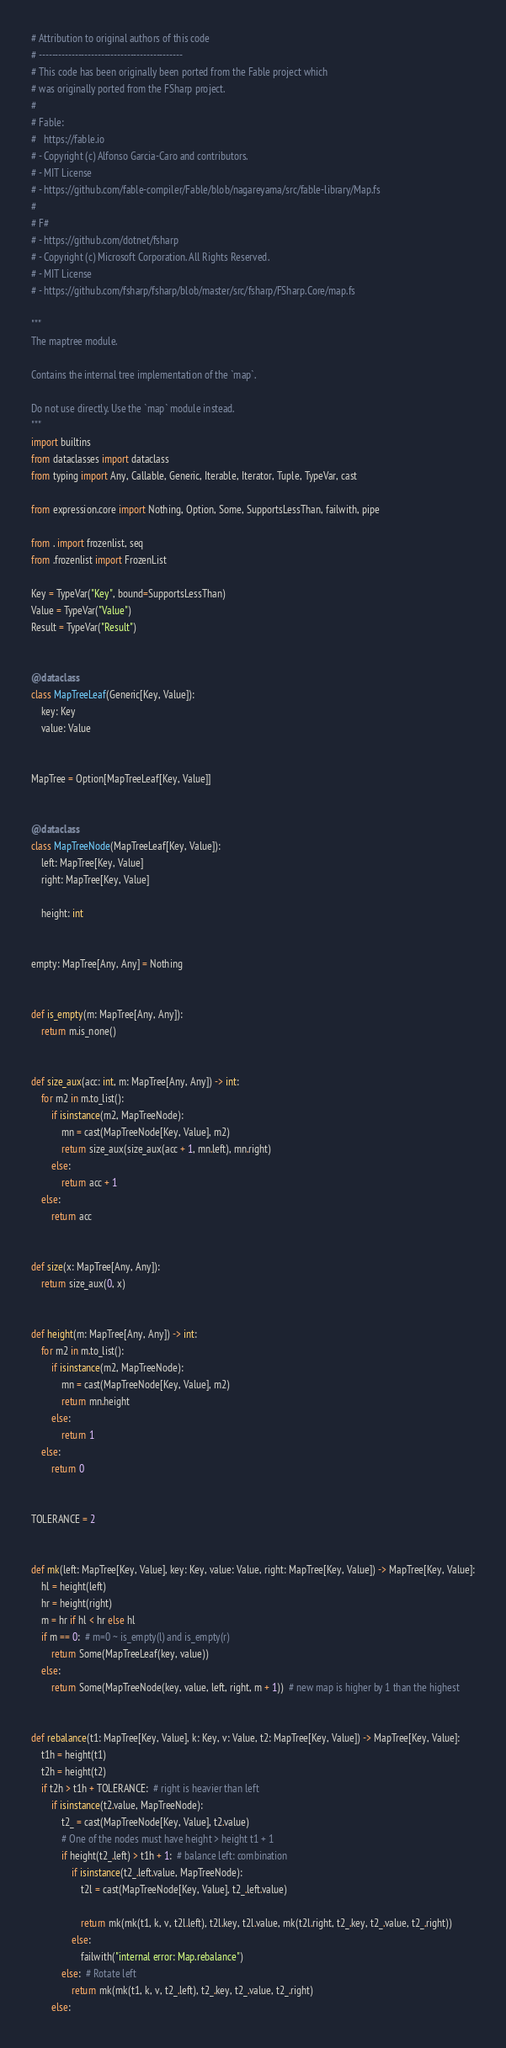Convert code to text. <code><loc_0><loc_0><loc_500><loc_500><_Python_># Attribution to original authors of this code
# --------------------------------------------
# This code has been originally been ported from the Fable project which
# was originally ported from the FSharp project.
#
# Fable:
#   https://fable.io
# - Copyright (c) Alfonso Garcia-Caro and contributors.
# - MIT License
# - https://github.com/fable-compiler/Fable/blob/nagareyama/src/fable-library/Map.fs
#
# F#
# - https://github.com/dotnet/fsharp
# - Copyright (c) Microsoft Corporation. All Rights Reserved.
# - MIT License
# - https://github.com/fsharp/fsharp/blob/master/src/fsharp/FSharp.Core/map.fs

"""
The maptree module.

Contains the internal tree implementation of the `map`.

Do not use directly. Use the `map` module instead.
"""
import builtins
from dataclasses import dataclass
from typing import Any, Callable, Generic, Iterable, Iterator, Tuple, TypeVar, cast

from expression.core import Nothing, Option, Some, SupportsLessThan, failwith, pipe

from . import frozenlist, seq
from .frozenlist import FrozenList

Key = TypeVar("Key", bound=SupportsLessThan)
Value = TypeVar("Value")
Result = TypeVar("Result")


@dataclass
class MapTreeLeaf(Generic[Key, Value]):
    key: Key
    value: Value


MapTree = Option[MapTreeLeaf[Key, Value]]


@dataclass
class MapTreeNode(MapTreeLeaf[Key, Value]):
    left: MapTree[Key, Value]
    right: MapTree[Key, Value]

    height: int


empty: MapTree[Any, Any] = Nothing


def is_empty(m: MapTree[Any, Any]):
    return m.is_none()


def size_aux(acc: int, m: MapTree[Any, Any]) -> int:
    for m2 in m.to_list():
        if isinstance(m2, MapTreeNode):
            mn = cast(MapTreeNode[Key, Value], m2)
            return size_aux(size_aux(acc + 1, mn.left), mn.right)
        else:
            return acc + 1
    else:
        return acc


def size(x: MapTree[Any, Any]):
    return size_aux(0, x)


def height(m: MapTree[Any, Any]) -> int:
    for m2 in m.to_list():
        if isinstance(m2, MapTreeNode):
            mn = cast(MapTreeNode[Key, Value], m2)
            return mn.height
        else:
            return 1
    else:
        return 0


TOLERANCE = 2


def mk(left: MapTree[Key, Value], key: Key, value: Value, right: MapTree[Key, Value]) -> MapTree[Key, Value]:
    hl = height(left)
    hr = height(right)
    m = hr if hl < hr else hl
    if m == 0:  # m=0 ~ is_empty(l) and is_empty(r)
        return Some(MapTreeLeaf(key, value))
    else:
        return Some(MapTreeNode(key, value, left, right, m + 1))  # new map is higher by 1 than the highest


def rebalance(t1: MapTree[Key, Value], k: Key, v: Value, t2: MapTree[Key, Value]) -> MapTree[Key, Value]:
    t1h = height(t1)
    t2h = height(t2)
    if t2h > t1h + TOLERANCE:  # right is heavier than left
        if isinstance(t2.value, MapTreeNode):
            t2_ = cast(MapTreeNode[Key, Value], t2.value)
            # One of the nodes must have height > height t1 + 1
            if height(t2_.left) > t1h + 1:  # balance left: combination
                if isinstance(t2_.left.value, MapTreeNode):
                    t2l = cast(MapTreeNode[Key, Value], t2_.left.value)

                    return mk(mk(t1, k, v, t2l.left), t2l.key, t2l.value, mk(t2l.right, t2_.key, t2_.value, t2_.right))
                else:
                    failwith("internal error: Map.rebalance")
            else:  # Rotate left
                return mk(mk(t1, k, v, t2_.left), t2_.key, t2_.value, t2_.right)
        else:</code> 